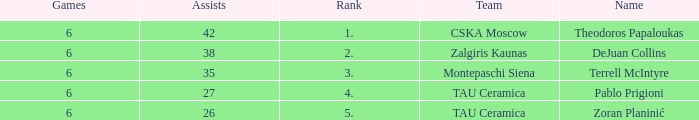What is the least number of assists among players ranked 2? 38.0. 